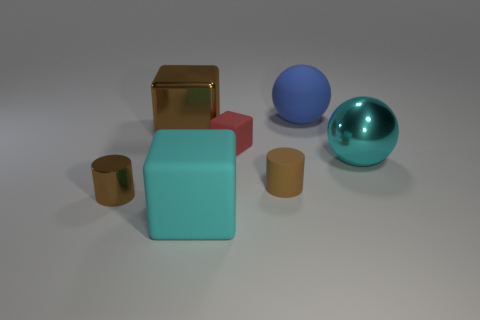Subtract all cyan matte blocks. How many blocks are left? 2 Subtract 1 blocks. How many blocks are left? 2 Add 1 small red blocks. How many objects exist? 8 Subtract all balls. How many objects are left? 5 Add 7 metal things. How many metal things exist? 10 Subtract 1 brown cylinders. How many objects are left? 6 Subtract all brown objects. Subtract all large red matte cylinders. How many objects are left? 4 Add 7 large blue things. How many large blue things are left? 8 